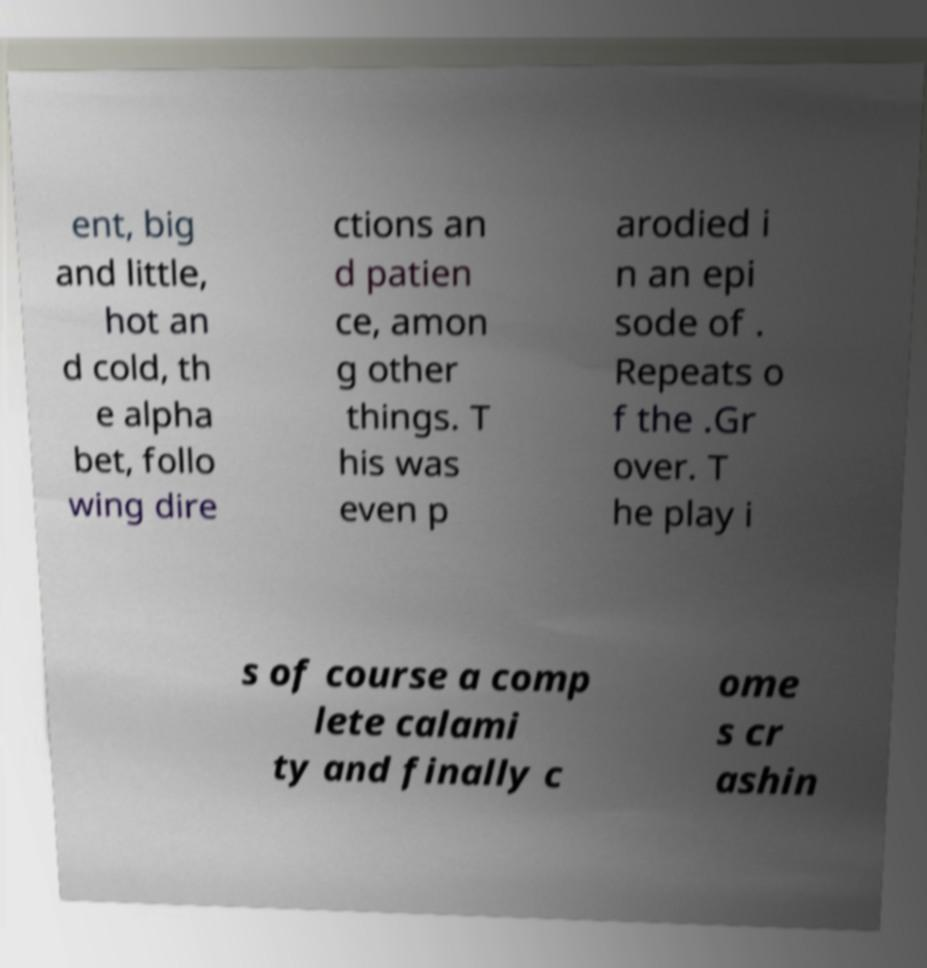I need the written content from this picture converted into text. Can you do that? ent, big and little, hot an d cold, th e alpha bet, follo wing dire ctions an d patien ce, amon g other things. T his was even p arodied i n an epi sode of . Repeats o f the .Gr over. T he play i s of course a comp lete calami ty and finally c ome s cr ashin 